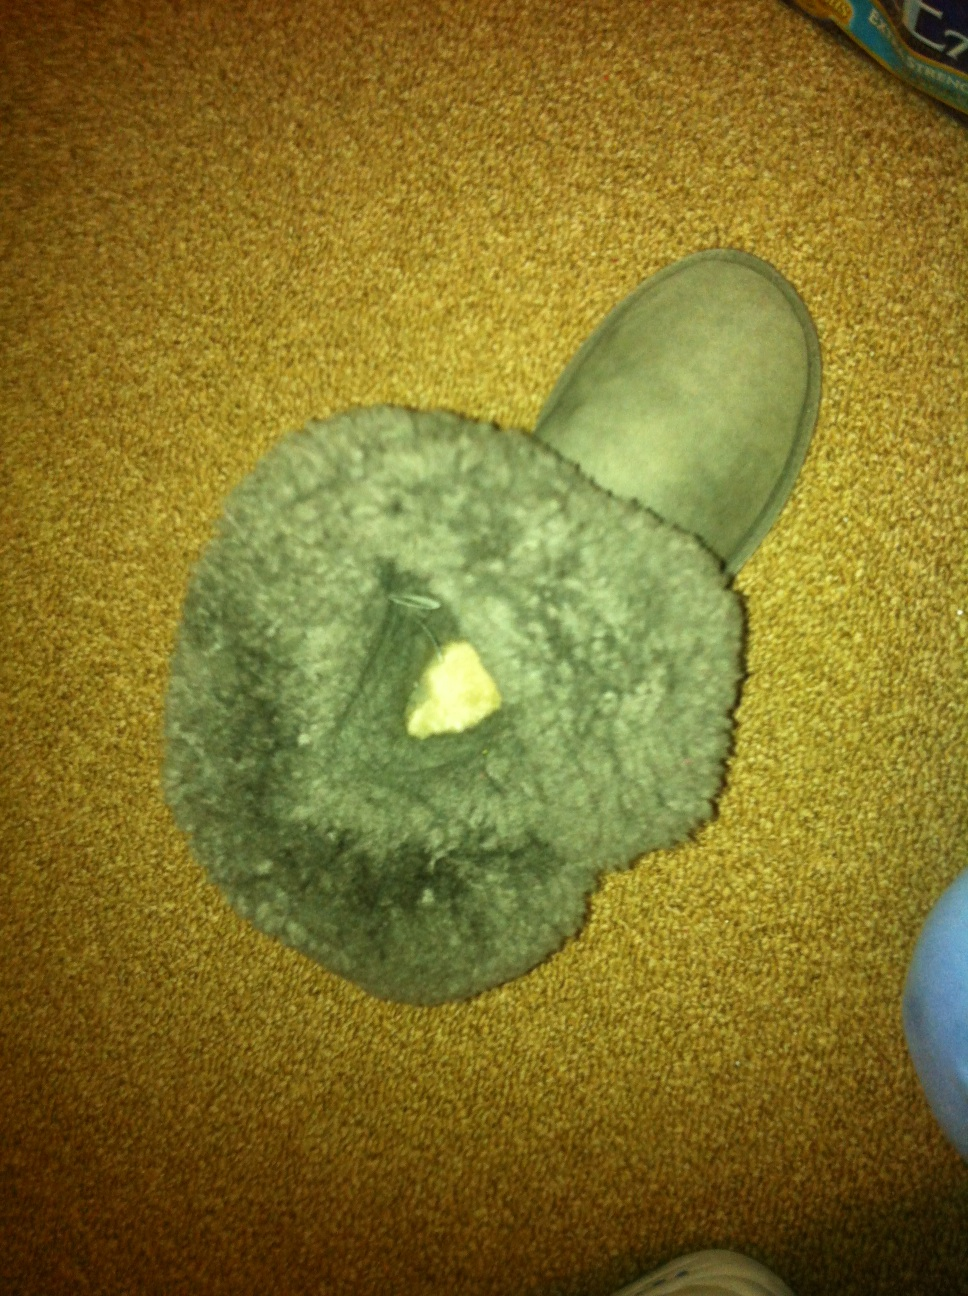How clean does this boot look? I just tried to wash it but there might still be some stains. The boot looks quite clean overall; however, there seem to be some subtle stains or marks, especially on the inner fur lining which could be due to remaining dirt or discoloration. To make it even cleaner, you might need to give it another wash or focus on the specific areas with gentle scrubbing. 